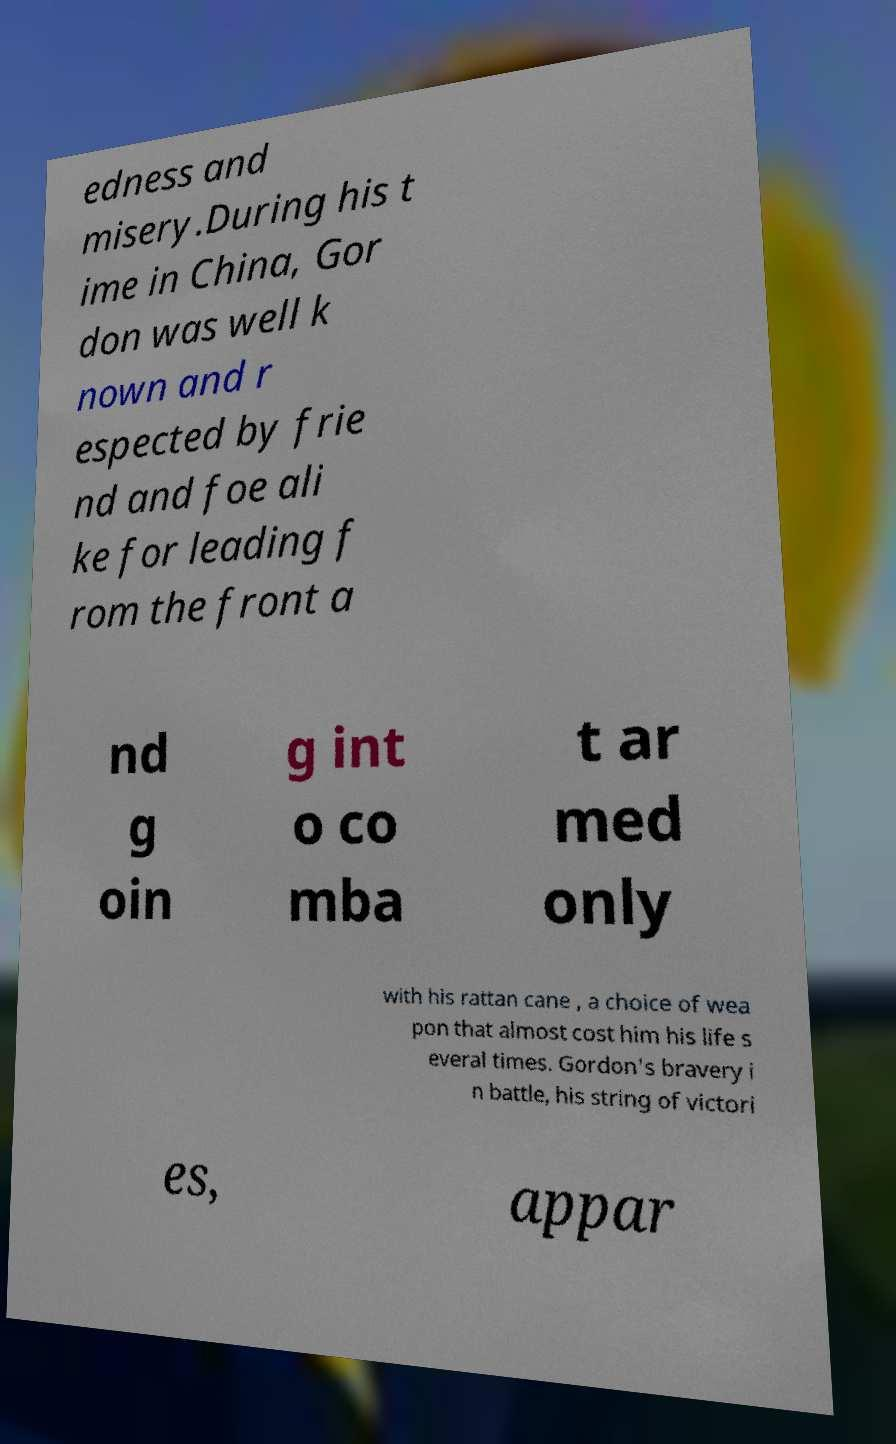What messages or text are displayed in this image? I need them in a readable, typed format. edness and misery.During his t ime in China, Gor don was well k nown and r espected by frie nd and foe ali ke for leading f rom the front a nd g oin g int o co mba t ar med only with his rattan cane , a choice of wea pon that almost cost him his life s everal times. Gordon's bravery i n battle, his string of victori es, appar 